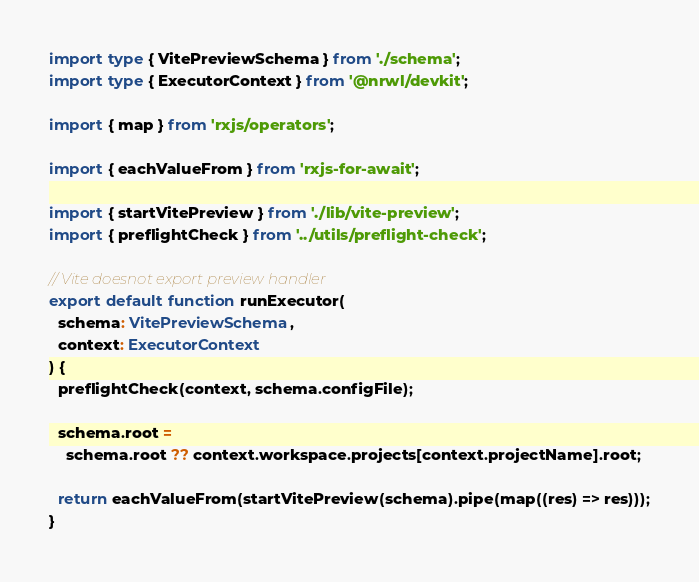<code> <loc_0><loc_0><loc_500><loc_500><_TypeScript_>import type { VitePreviewSchema } from './schema';
import type { ExecutorContext } from '@nrwl/devkit';

import { map } from 'rxjs/operators';

import { eachValueFrom } from 'rxjs-for-await';

import { startVitePreview } from './lib/vite-preview';
import { preflightCheck } from '../utils/preflight-check';

// Vite doesnot export preview handler
export default function runExecutor(
  schema: VitePreviewSchema,
  context: ExecutorContext
) {
  preflightCheck(context, schema.configFile);

  schema.root =
    schema.root ?? context.workspace.projects[context.projectName].root;

  return eachValueFrom(startVitePreview(schema).pipe(map((res) => res)));
}
</code> 